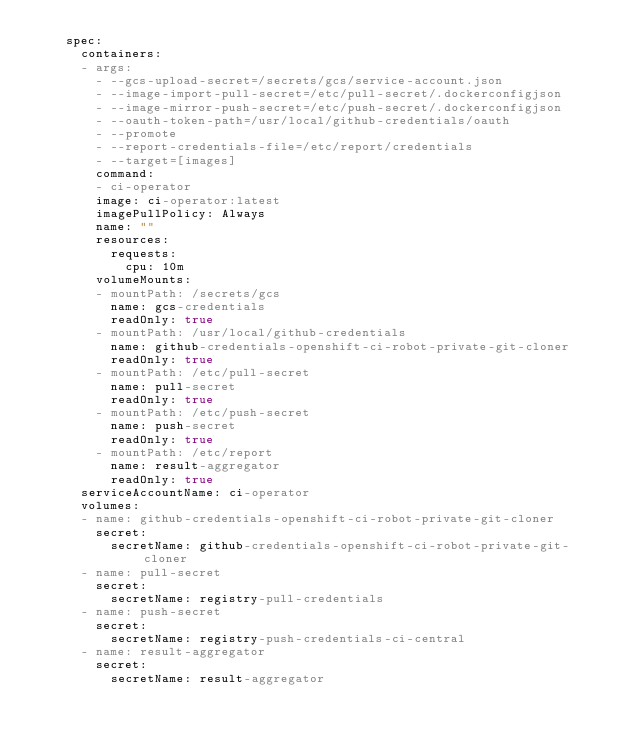<code> <loc_0><loc_0><loc_500><loc_500><_YAML_>    spec:
      containers:
      - args:
        - --gcs-upload-secret=/secrets/gcs/service-account.json
        - --image-import-pull-secret=/etc/pull-secret/.dockerconfigjson
        - --image-mirror-push-secret=/etc/push-secret/.dockerconfigjson
        - --oauth-token-path=/usr/local/github-credentials/oauth
        - --promote
        - --report-credentials-file=/etc/report/credentials
        - --target=[images]
        command:
        - ci-operator
        image: ci-operator:latest
        imagePullPolicy: Always
        name: ""
        resources:
          requests:
            cpu: 10m
        volumeMounts:
        - mountPath: /secrets/gcs
          name: gcs-credentials
          readOnly: true
        - mountPath: /usr/local/github-credentials
          name: github-credentials-openshift-ci-robot-private-git-cloner
          readOnly: true
        - mountPath: /etc/pull-secret
          name: pull-secret
          readOnly: true
        - mountPath: /etc/push-secret
          name: push-secret
          readOnly: true
        - mountPath: /etc/report
          name: result-aggregator
          readOnly: true
      serviceAccountName: ci-operator
      volumes:
      - name: github-credentials-openshift-ci-robot-private-git-cloner
        secret:
          secretName: github-credentials-openshift-ci-robot-private-git-cloner
      - name: pull-secret
        secret:
          secretName: registry-pull-credentials
      - name: push-secret
        secret:
          secretName: registry-push-credentials-ci-central
      - name: result-aggregator
        secret:
          secretName: result-aggregator
</code> 